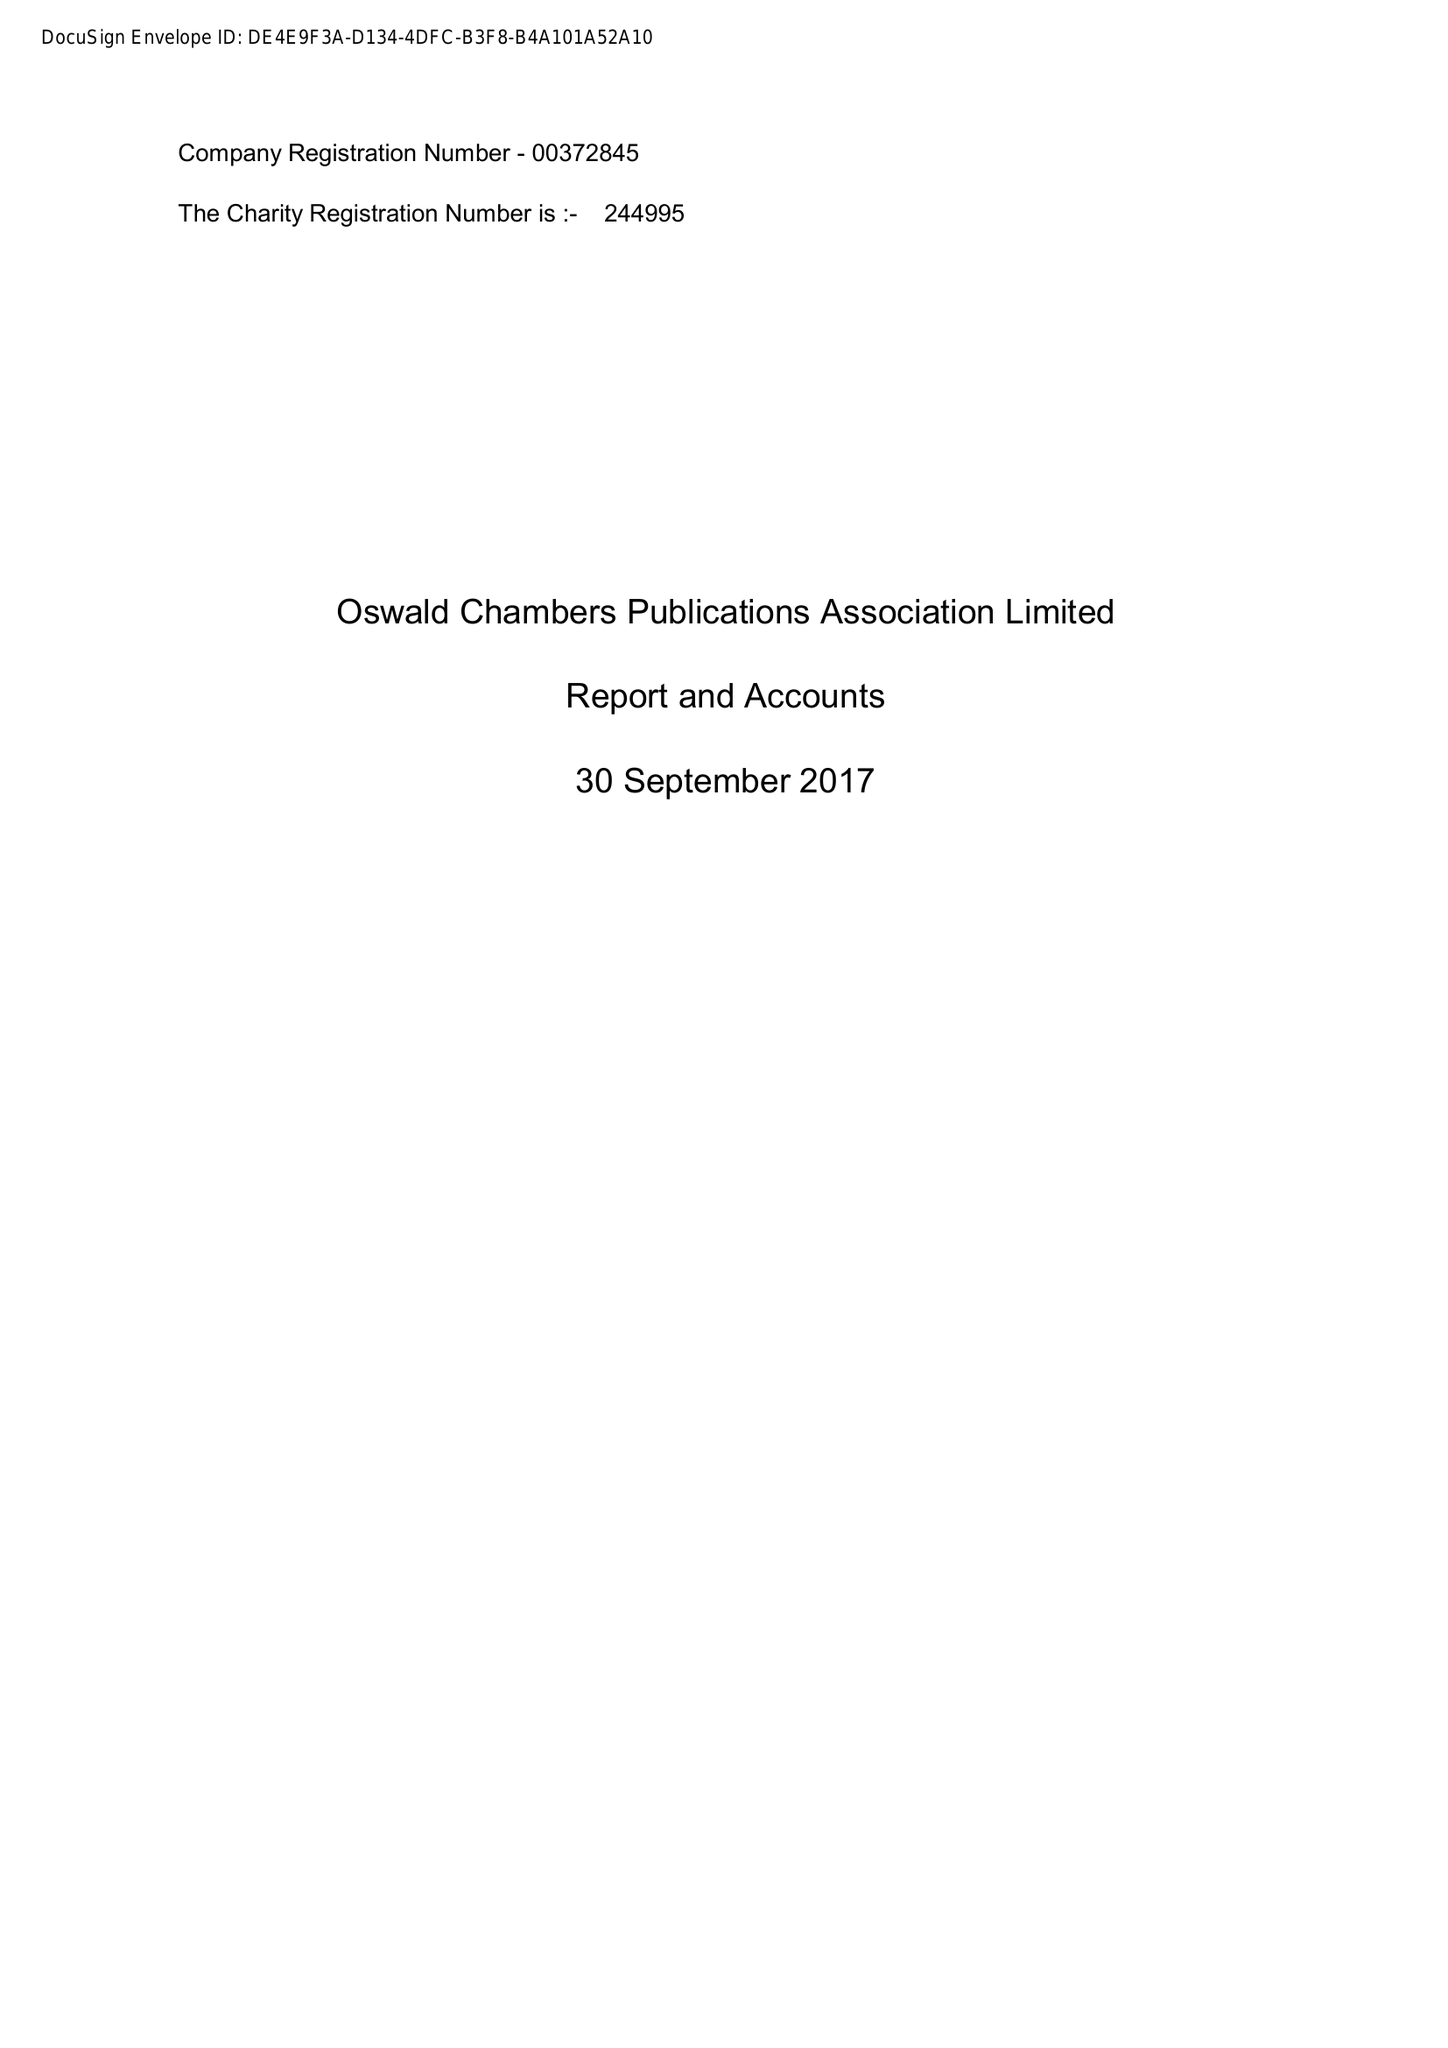What is the value for the address__postcode?
Answer the question using a single word or phrase. CW1 3BY 